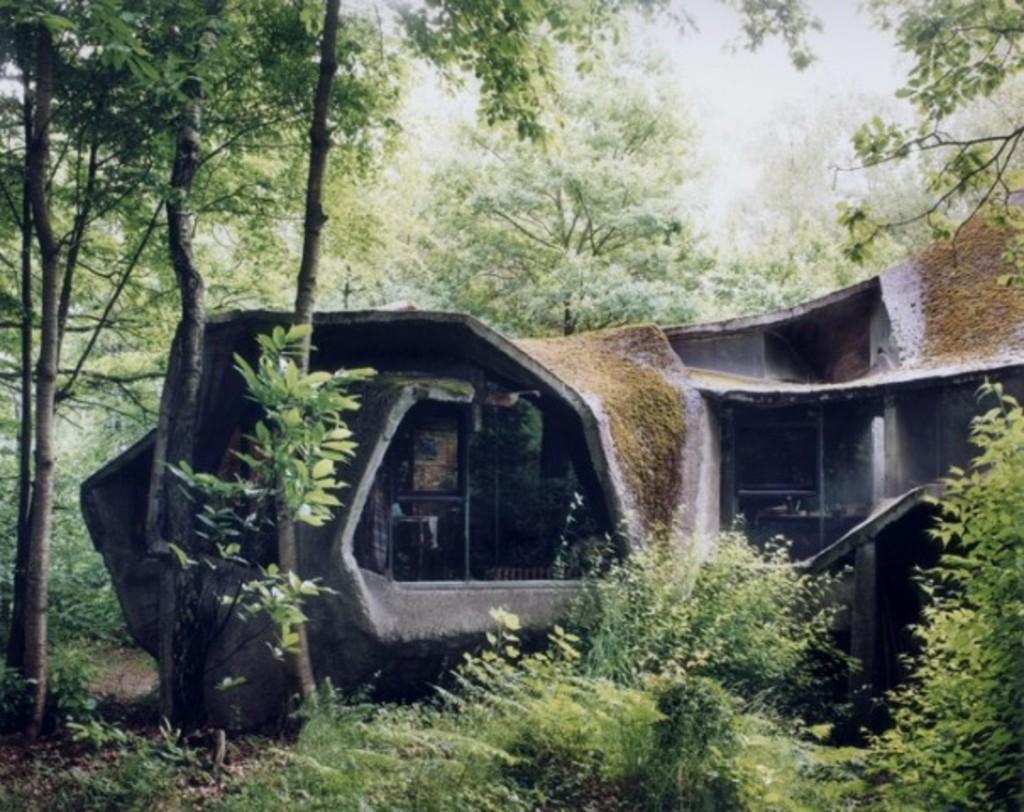Can you describe this image briefly? In this image I can see a building and windows. I can see few trees. 